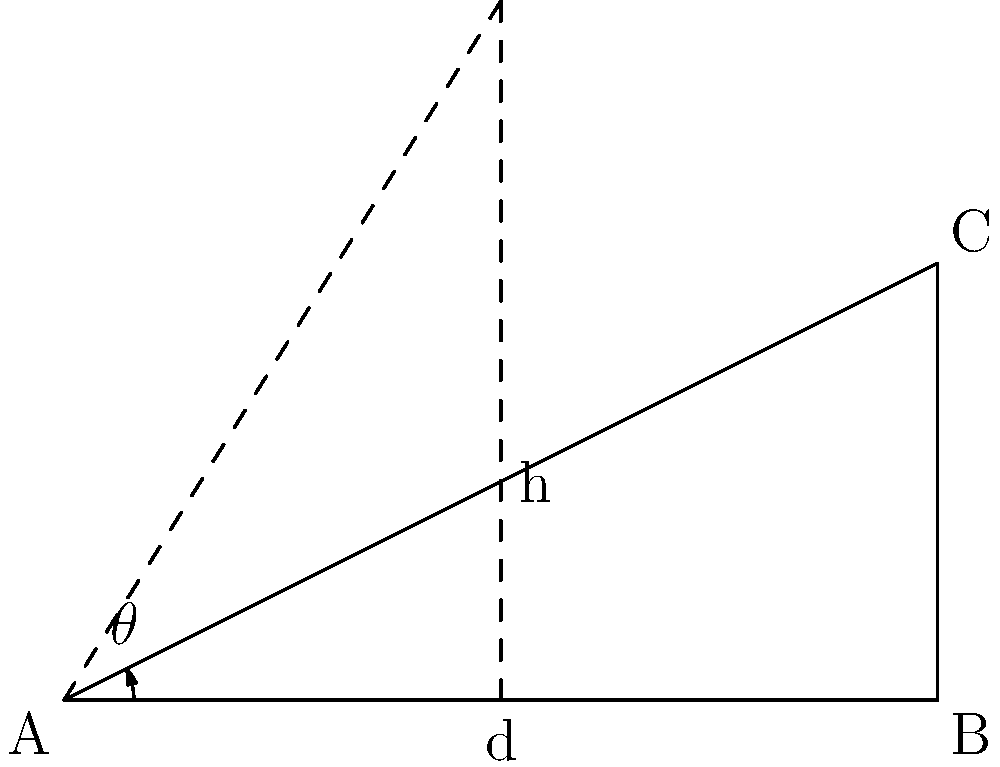As a basketball player, you're analyzing the optimal angle for a free throw shot. The distance from the free throw line to the backboard is 4.6 meters, and the height of the hoop is 3.05 meters above the ground. What is the optimal angle $\theta$ (in degrees) for the shot, assuming the ball is released at a height of 2.1 meters? Let's approach this step-by-step:

1) First, we need to find the effective height difference between the release point and the hoop:
   $h = 3.05m - 2.1m = 0.95m$

2) Now we have a right triangle where:
   - The base (d) is 4.6m (distance to the backboard)
   - The height (h) is 0.95m (effective height difference)

3) We can find the angle $\theta$ using the tangent function:

   $$\tan(\theta) = \frac{\text{opposite}}{\text{adjacent}} = \frac{h}{d} = \frac{0.95}{4.6}$$

4) To find $\theta$, we take the inverse tangent (arctan) of this ratio:

   $$\theta = \arctan(\frac{0.95}{4.6})$$

5) Using a calculator or programming function, we can compute this:

   $$\theta \approx 11.67^\circ$$

6) However, this is the angle to hit the hoop directly. For an optimal shot, we typically aim for a slightly higher angle to increase the chances of the ball going through the hoop. A common rule of thumb is to add about 5 degrees to this angle.

7) Therefore, the optimal angle would be:

   $$\theta_{\text{optimal}} \approx 11.67^\circ + 5^\circ = 16.67^\circ$$

8) Rounding to the nearest degree for practical application:

   $$\theta_{\text{optimal}} \approx 17^\circ$$
Answer: $17^\circ$ 